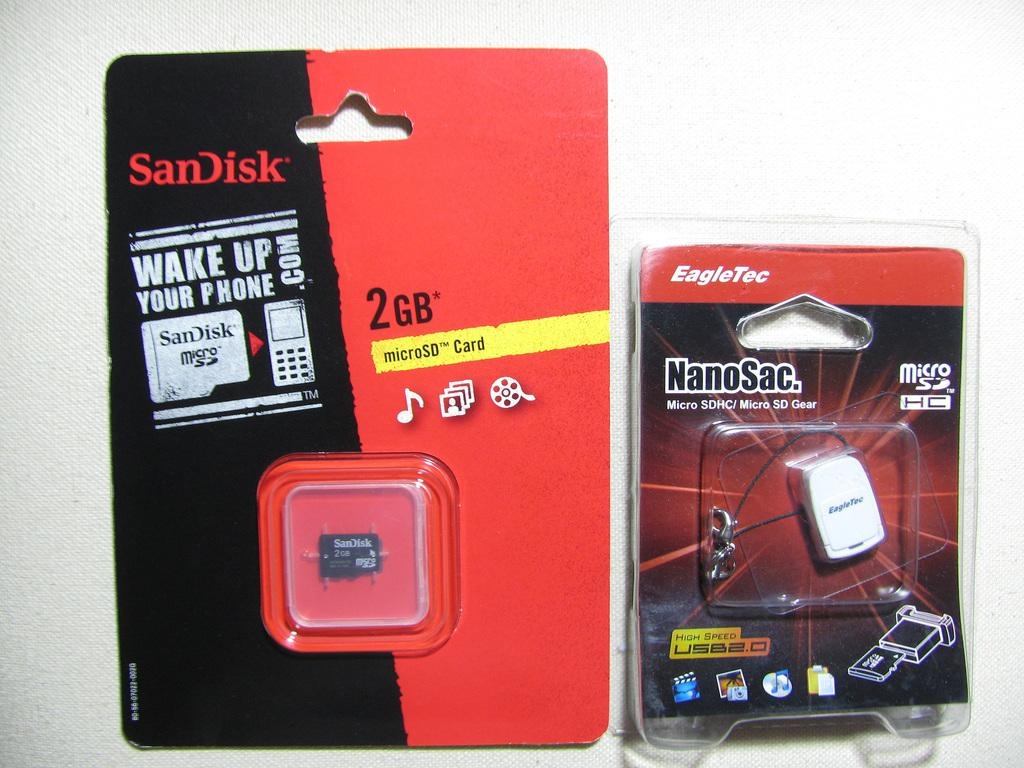<image>
Write a terse but informative summary of the picture. micro memory card for mobile device two gigs 